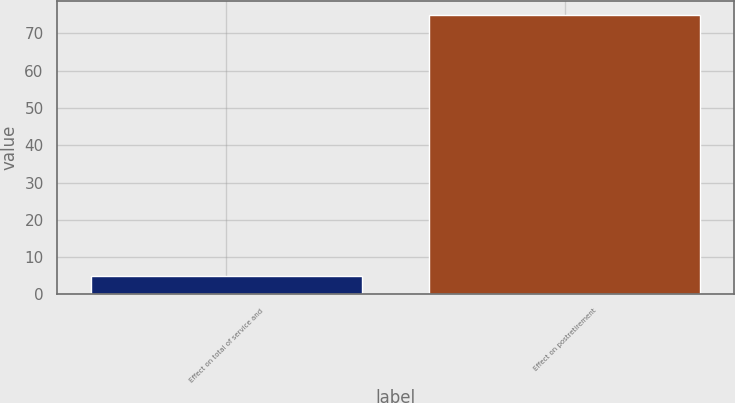Convert chart to OTSL. <chart><loc_0><loc_0><loc_500><loc_500><bar_chart><fcel>Effect on total of service and<fcel>Effect on postretirement<nl><fcel>5<fcel>75<nl></chart> 